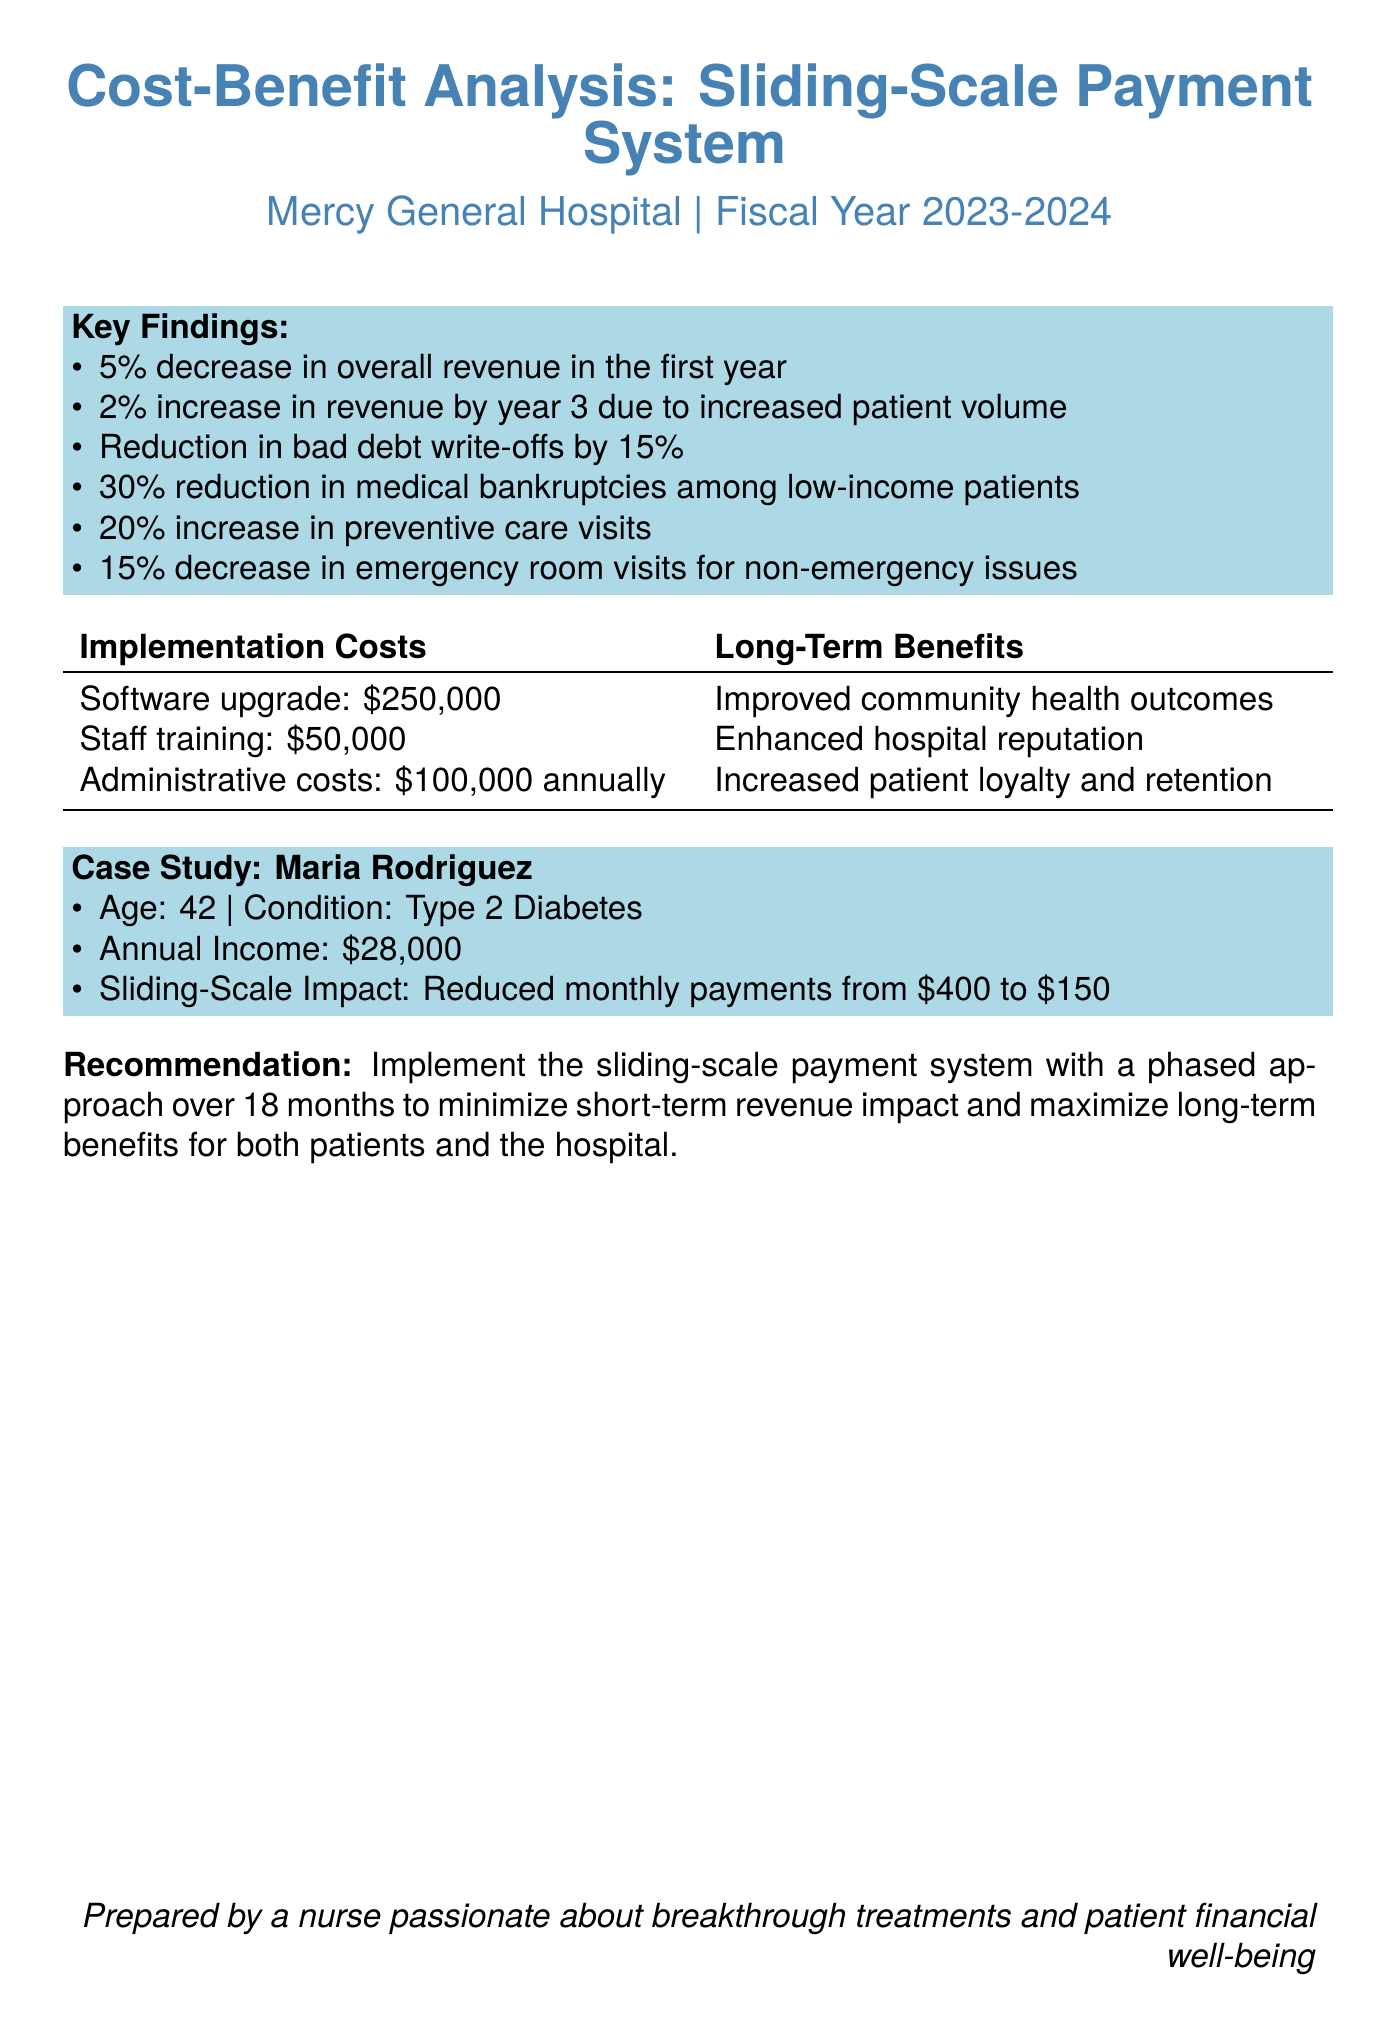What is the hospital name? The hospital's name is specified at the beginning of the report.
Answer: Mercy General Hospital What is the analysis period for this report? The analysis period is mentioned in the header of the document.
Answer: Fiscal Year 2023-2024 What is the projected revenue change in the first year? The projected revenue change is highlighted in the key findings section.
Answer: 5% decrease By what percentage is revenue expected to increase by year three? The expected increase in revenue by year three is included in the key findings.
Answer: 2% What were the implementation costs for software upgrades? The implementation costs are detailed in the table of implementation costs.
Answer: $250,000 What is the percentage reduction in medical bankruptcies among low-income patients? This information is found in the patient financial outcomes section.
Answer: 30% What is the age of the case study patient, Maria Rodriguez? The patient's age is listed in the case study section of the document.
Answer: 42 What is the recommended approach for implementing the sliding-scale payment system? The recommendation section outlines the proposed strategy for implementation.
Answer: Phased approach over 18 months What improvement is expected in preventive care visits? The expected improvement is noted in the patient financial outcomes.
Answer: 20% increase What is the total administrative cost annually? The annual administrative cost is specified in the implementation costs table.
Answer: $100,000 